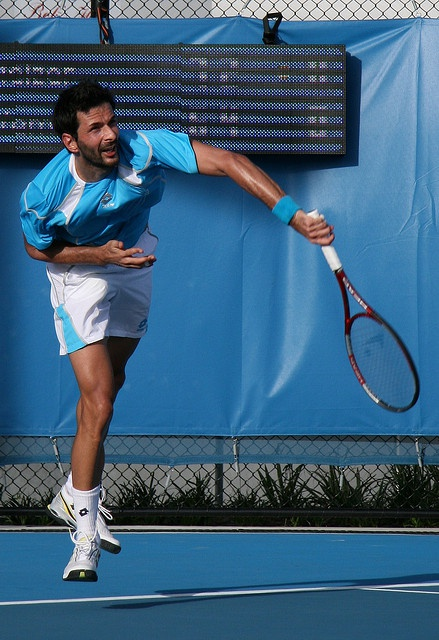Describe the objects in this image and their specific colors. I can see people in darkgray, black, brown, lightgray, and navy tones and tennis racket in darkgray, teal, black, blue, and navy tones in this image. 